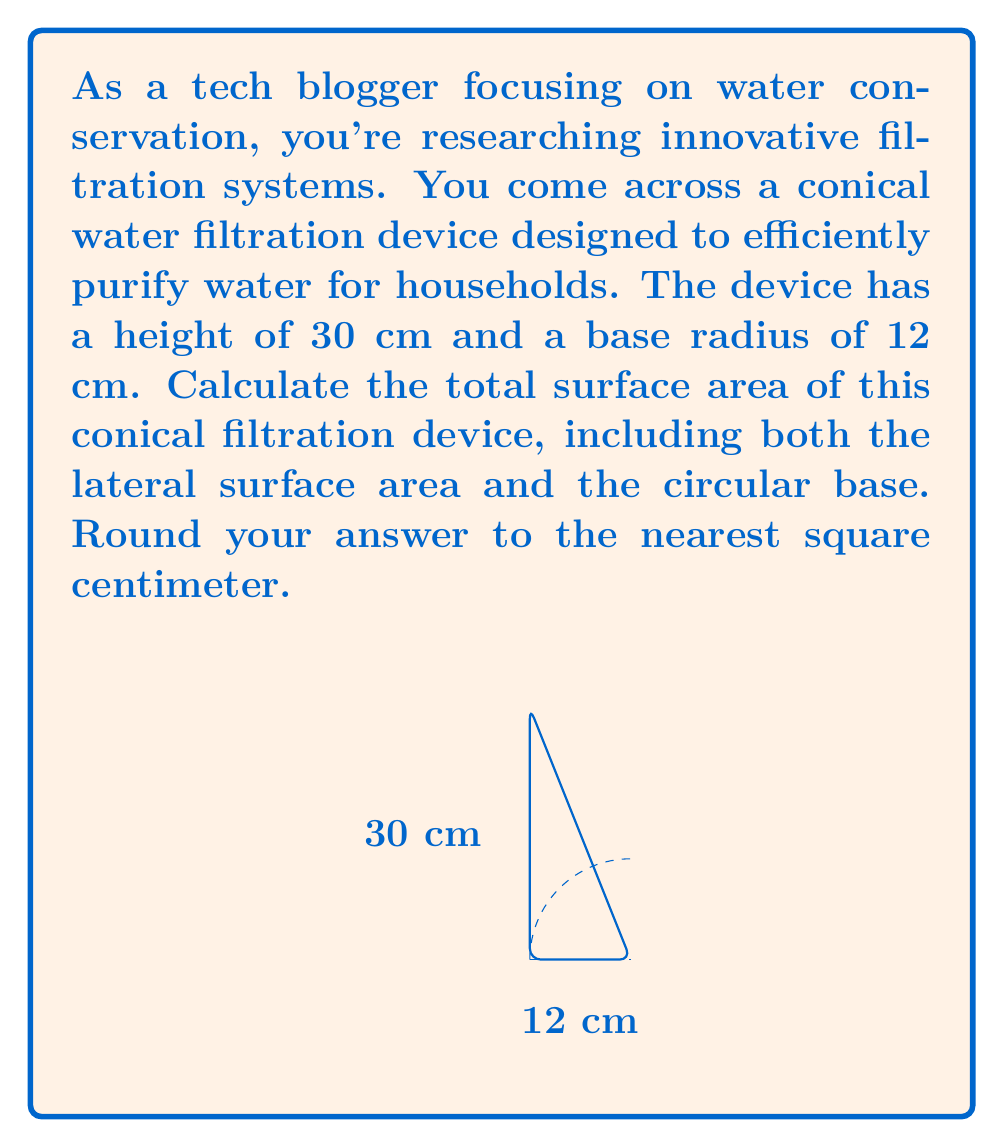Can you solve this math problem? To solve this problem, we need to calculate the lateral surface area of the cone and add it to the area of the circular base. Let's break it down step by step:

1) First, we need to find the slant height of the cone. We can do this using the Pythagorean theorem:

   $$ s = \sqrt{r^2 + h^2} $$

   where $s$ is the slant height, $r$ is the radius, and $h$ is the height.

   $$ s = \sqrt{12^2 + 30^2} = \sqrt{144 + 900} = \sqrt{1044} \approx 32.31 \text{ cm} $$

2) Now we can calculate the lateral surface area of the cone using the formula:

   $$ A_{\text{lateral}} = \pi r s $$

   $$ A_{\text{lateral}} = \pi \cdot 12 \cdot 32.31 \approx 1218.71 \text{ cm}^2 $$

3) The area of the circular base is given by:

   $$ A_{\text{base}} = \pi r^2 $$

   $$ A_{\text{base}} = \pi \cdot 12^2 = 144\pi \approx 452.39 \text{ cm}^2 $$

4) The total surface area is the sum of the lateral surface area and the base area:

   $$ A_{\text{total}} = A_{\text{lateral}} + A_{\text{base}} $$

   $$ A_{\text{total}} \approx 1218.71 + 452.39 = 1671.10 \text{ cm}^2 $$

5) Rounding to the nearest square centimeter:

   $$ A_{\text{total}} \approx 1671 \text{ cm}^2 $$
Answer: The total surface area of the conical water filtration device is approximately 1671 cm². 